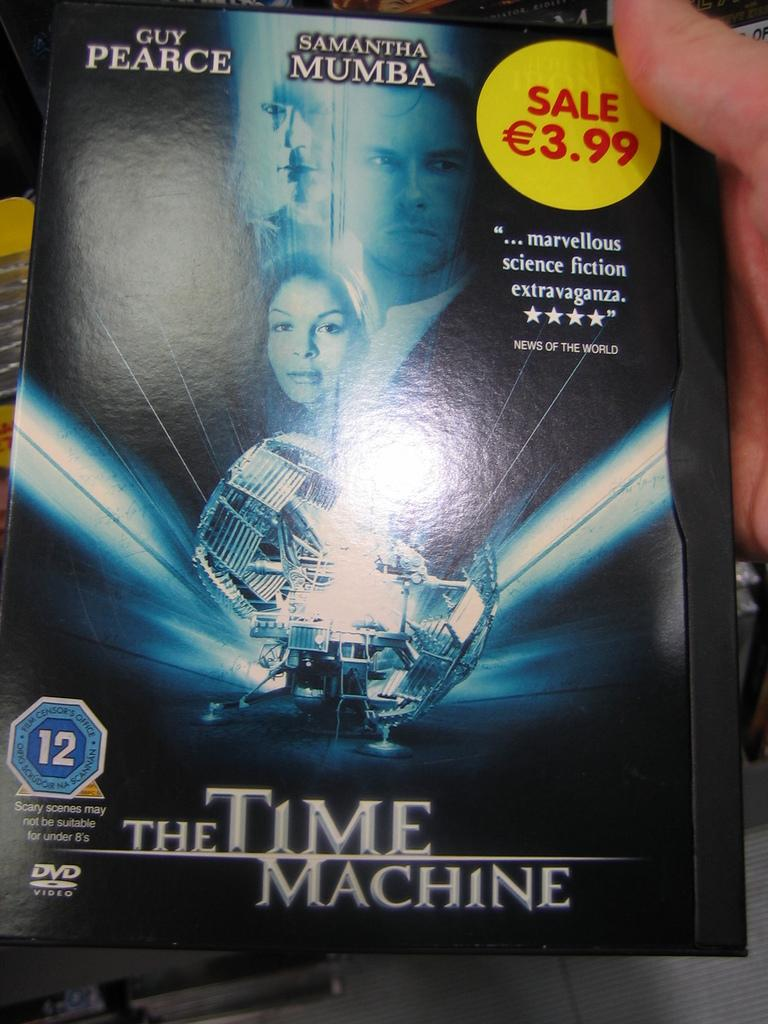<image>
Present a compact description of the photo's key features. A DVD cover for the Time Machine by Guy Pearce. 